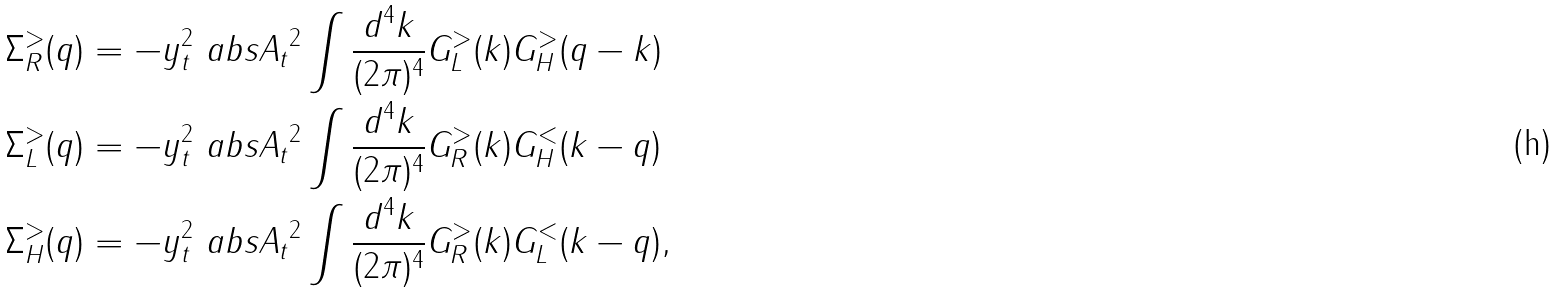<formula> <loc_0><loc_0><loc_500><loc_500>\Sigma _ { R } ^ { > } ( q ) & = - y _ { t } ^ { 2 } \ a b s { A _ { t } } ^ { 2 } \int \frac { d ^ { 4 } k } { ( 2 \pi ) ^ { 4 } } G _ { L } ^ { > } ( k ) G _ { H } ^ { > } ( q - k ) \\ \Sigma _ { L } ^ { > } ( q ) & = - y _ { t } ^ { 2 } \ a b s { A _ { t } } ^ { 2 } \int \frac { d ^ { 4 } k } { ( 2 \pi ) ^ { 4 } } G _ { R } ^ { > } ( k ) G _ { H } ^ { < } ( k - q ) \\ \Sigma _ { H } ^ { > } ( q ) & = - y _ { t } ^ { 2 } \ a b s { A _ { t } } ^ { 2 } \int \frac { d ^ { 4 } k } { ( 2 \pi ) ^ { 4 } } G _ { R } ^ { > } ( k ) G _ { L } ^ { < } ( k - q ) ,</formula> 